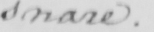Please provide the text content of this handwritten line. snare . 